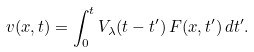<formula> <loc_0><loc_0><loc_500><loc_500>v ( x , t ) = \int _ { 0 } ^ { t } V _ { \lambda } ( t - t ^ { \prime } ) \, F ( x , t ^ { \prime } ) \, d t ^ { \prime } .</formula> 